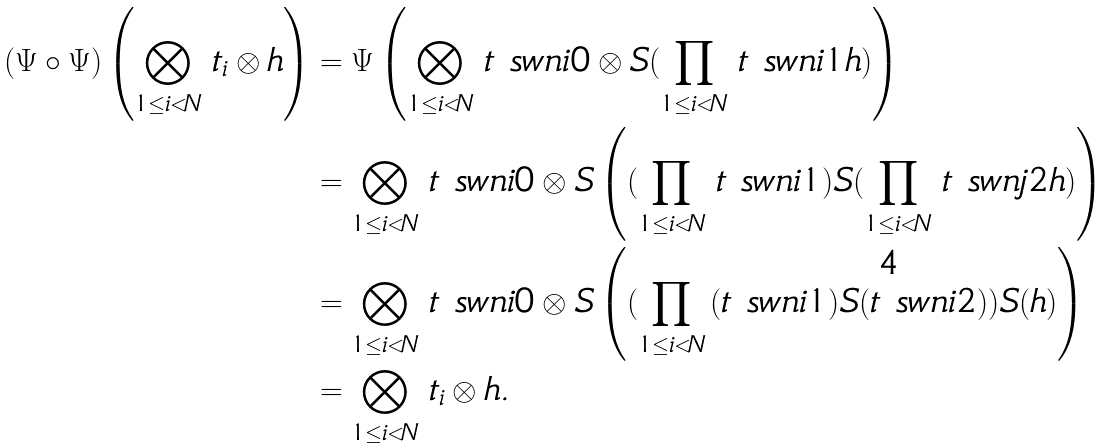<formula> <loc_0><loc_0><loc_500><loc_500>( \Psi \circ \Psi ) \left ( \bigotimes _ { 1 \leq i < N } \, t _ { i } \otimes h \right ) & = \Psi \left ( \bigotimes _ { 1 \leq i < N } \, t \ s w n { i } { 0 } \otimes S ( \prod _ { 1 \leq i < N } \, t \ s w n { i } { 1 } h ) \right ) \\ & = \bigotimes _ { 1 \leq i < N } \, t \ s w n { i } { 0 } \otimes S \left ( ( \prod _ { 1 \leq i < N } \, t \ s w n { i } { 1 } ) S ( \prod _ { 1 \leq i < N } \, t \ s w n { j } { 2 } h ) \right ) \\ & = \bigotimes _ { 1 \leq i < N } \, t \ s w n { i } { 0 } \otimes S \left ( ( \prod _ { 1 \leq i < N } \, ( t \ s w n { i } { 1 } ) S ( t \ s w n { i } { 2 } ) ) S ( h ) \right ) \\ & = \bigotimes _ { 1 \leq i < N } \, t _ { i } \otimes h .</formula> 